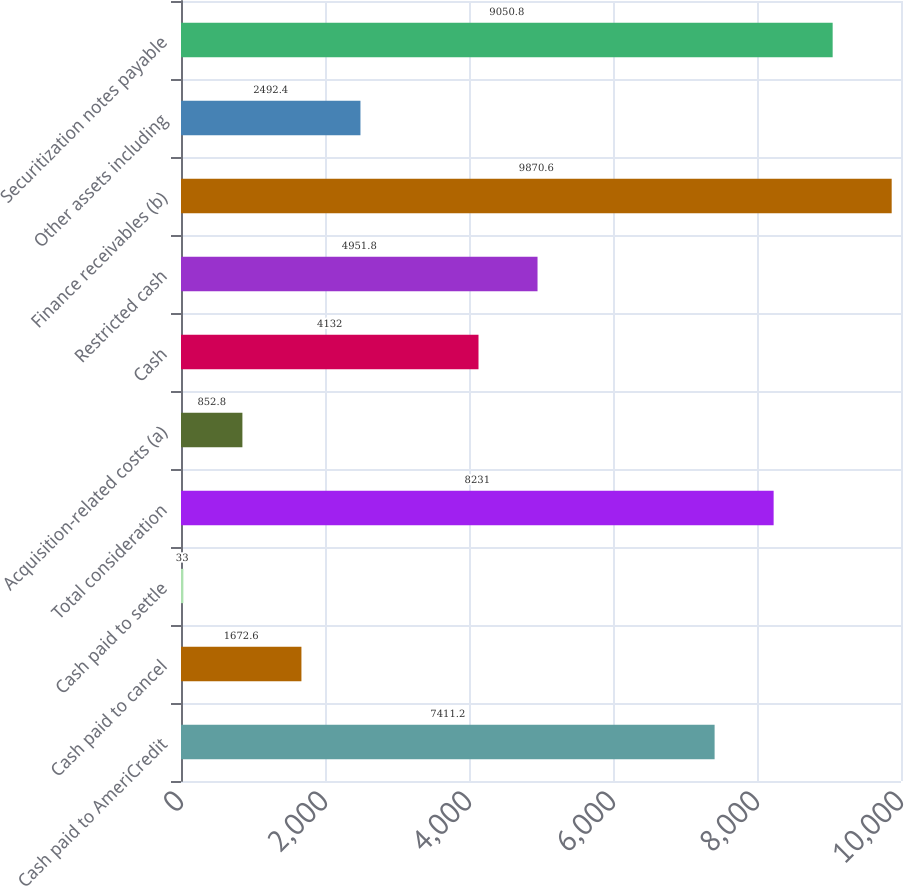<chart> <loc_0><loc_0><loc_500><loc_500><bar_chart><fcel>Cash paid to AmeriCredit<fcel>Cash paid to cancel<fcel>Cash paid to settle<fcel>Total consideration<fcel>Acquisition-related costs (a)<fcel>Cash<fcel>Restricted cash<fcel>Finance receivables (b)<fcel>Other assets including<fcel>Securitization notes payable<nl><fcel>7411.2<fcel>1672.6<fcel>33<fcel>8231<fcel>852.8<fcel>4132<fcel>4951.8<fcel>9870.6<fcel>2492.4<fcel>9050.8<nl></chart> 